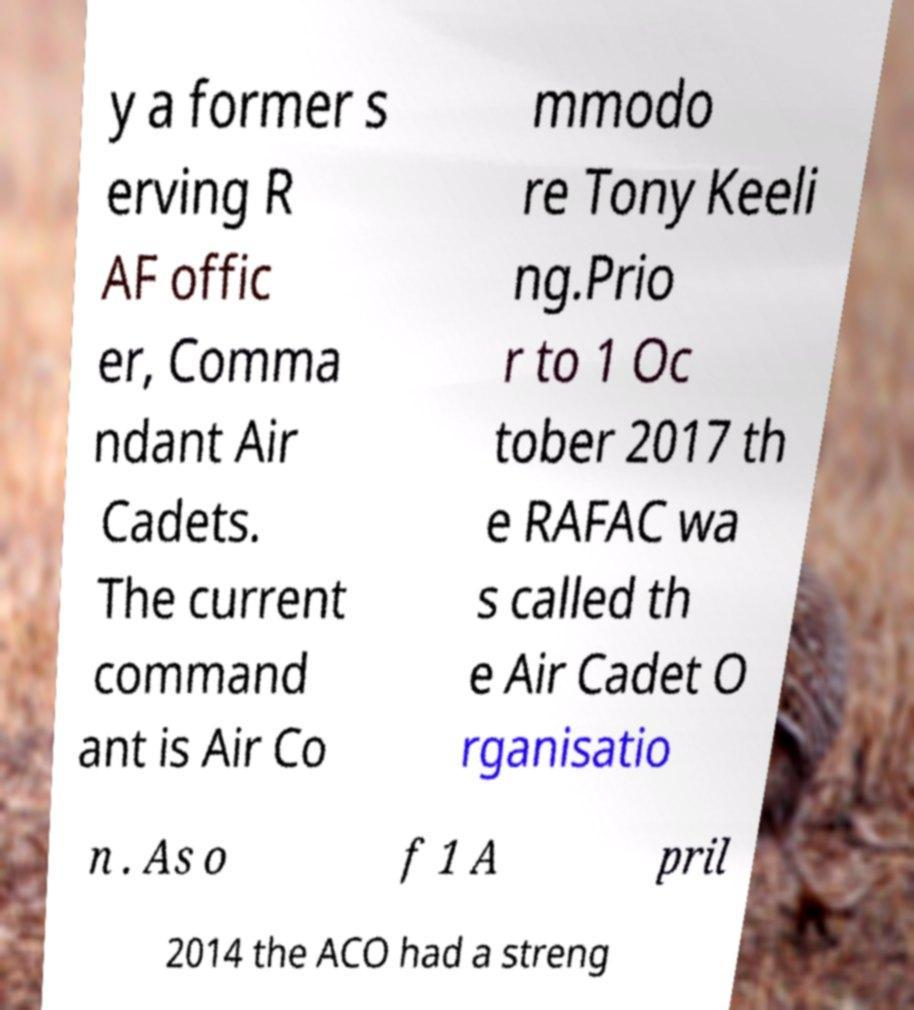Can you accurately transcribe the text from the provided image for me? y a former s erving R AF offic er, Comma ndant Air Cadets. The current command ant is Air Co mmodo re Tony Keeli ng.Prio r to 1 Oc tober 2017 th e RAFAC wa s called th e Air Cadet O rganisatio n . As o f 1 A pril 2014 the ACO had a streng 